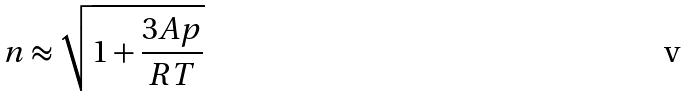Convert formula to latex. <formula><loc_0><loc_0><loc_500><loc_500>n \approx \sqrt { 1 + \frac { 3 A p } { R T } }</formula> 